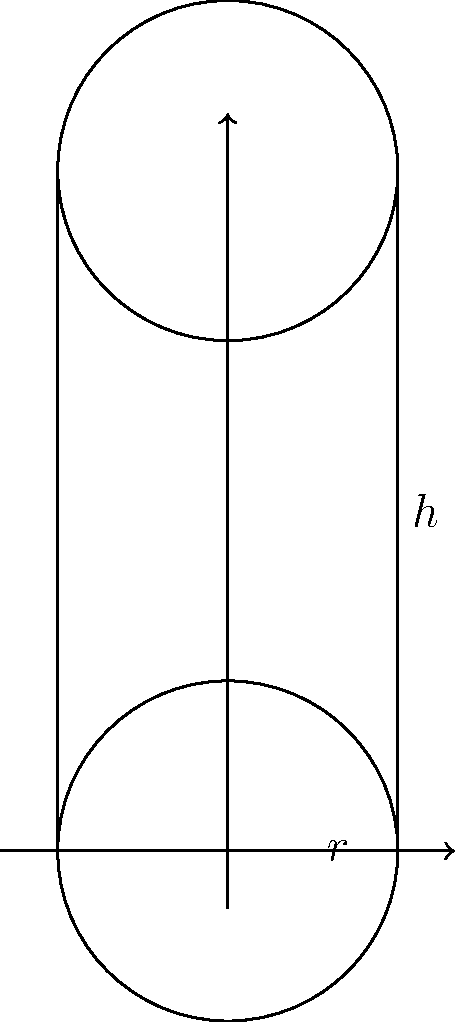As a pharmaceutical science researcher specializing in bioequivalence studies, you need to calculate the surface area of a cylindrical pill bottle. The bottle has a radius of 1.5 cm and a height of 6 cm. What is the total surface area of the pill bottle, including the top and bottom circular faces? Round your answer to the nearest 0.01 cm². To calculate the surface area of a cylindrical pill bottle, we need to consider three components:

1. The lateral surface area (curved surface)
2. The area of the top circular face
3. The area of the bottom circular face

Let's solve this step-by-step:

1. Lateral surface area:
   - Formula: $A_lateral = 2\pi rh$
   - $A_lateral = 2\pi \cdot 1.5 \text{ cm} \cdot 6 \text{ cm} = 18\pi \text{ cm}^2$

2. Area of one circular face:
   - Formula: $A_circle = \pi r^2$
   - $A_circle = \pi \cdot (1.5 \text{ cm})^2 = 2.25\pi \text{ cm}^2$

3. Total surface area:
   - $A_total = A_lateral + 2 \cdot A_circle$
   - $A_total = 18\pi \text{ cm}^2 + 2 \cdot 2.25\pi \text{ cm}^2$
   - $A_total = 22.5\pi \text{ cm}^2$

4. Convert to numerical value:
   - $A_total = 22.5 \cdot 3.14159... \text{ cm}^2 \approx 70.69 \text{ cm}^2$

5. Round to the nearest 0.01 cm²:
   - $A_total \approx 70.69 \text{ cm}^2$

Therefore, the total surface area of the cylindrical pill bottle is approximately 70.69 cm².
Answer: 70.69 cm² 